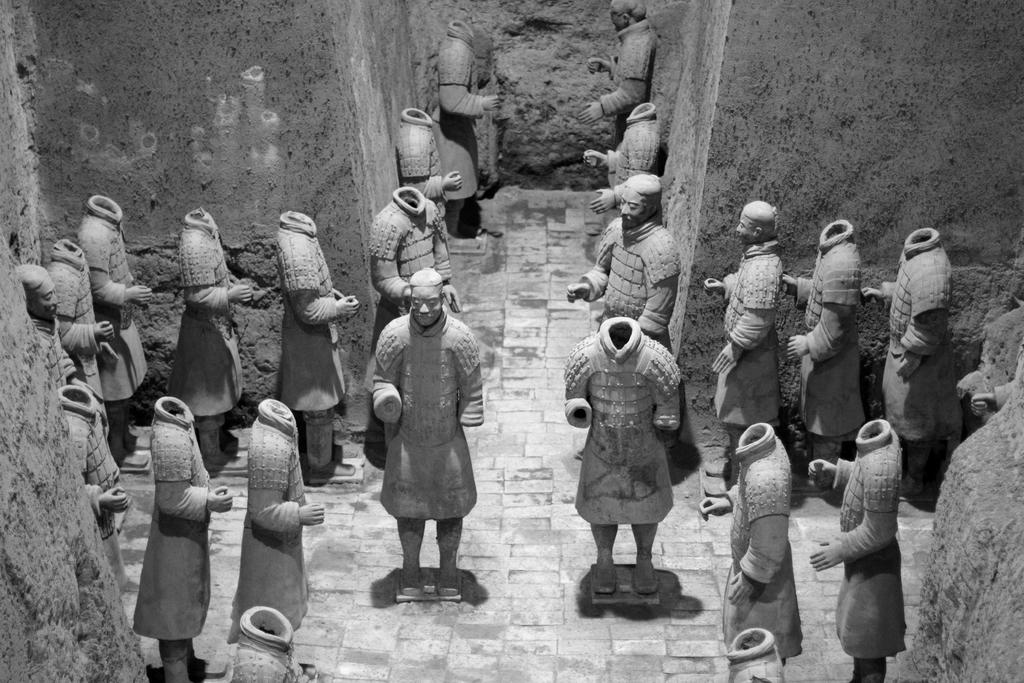What type of objects can be seen in the room? There are many sculptures in the room. Can you describe the sculptures in more detail? Some of the sculptures have heads, while others are headless. How many houses can be seen in the room? There are no houses present in the room; it contains sculptures. 